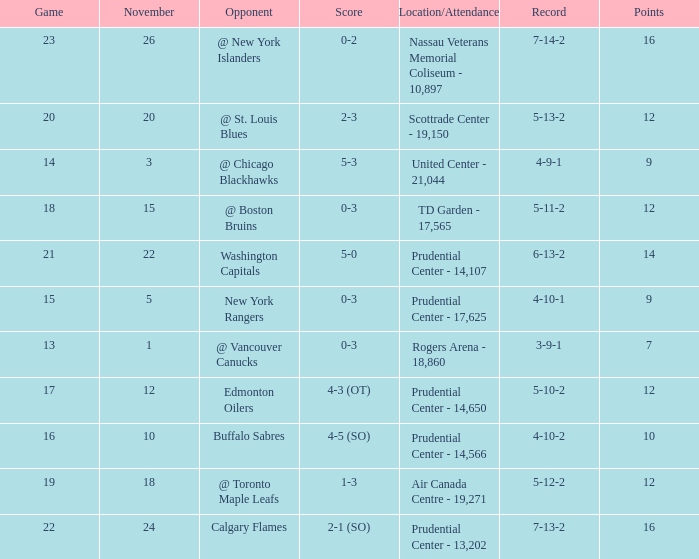Who was the opponent where the game is 14? @ Chicago Blackhawks. 